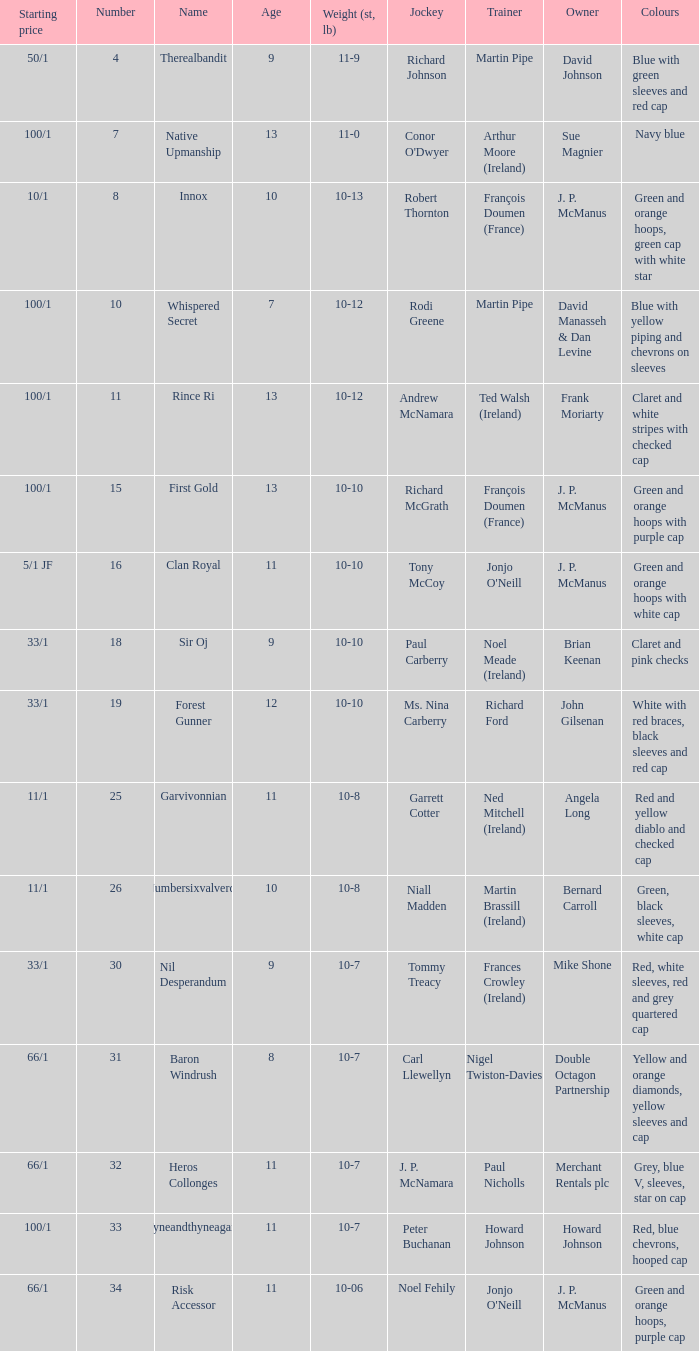What was the name of the participant with an owner named david johnson? Therealbandit. 